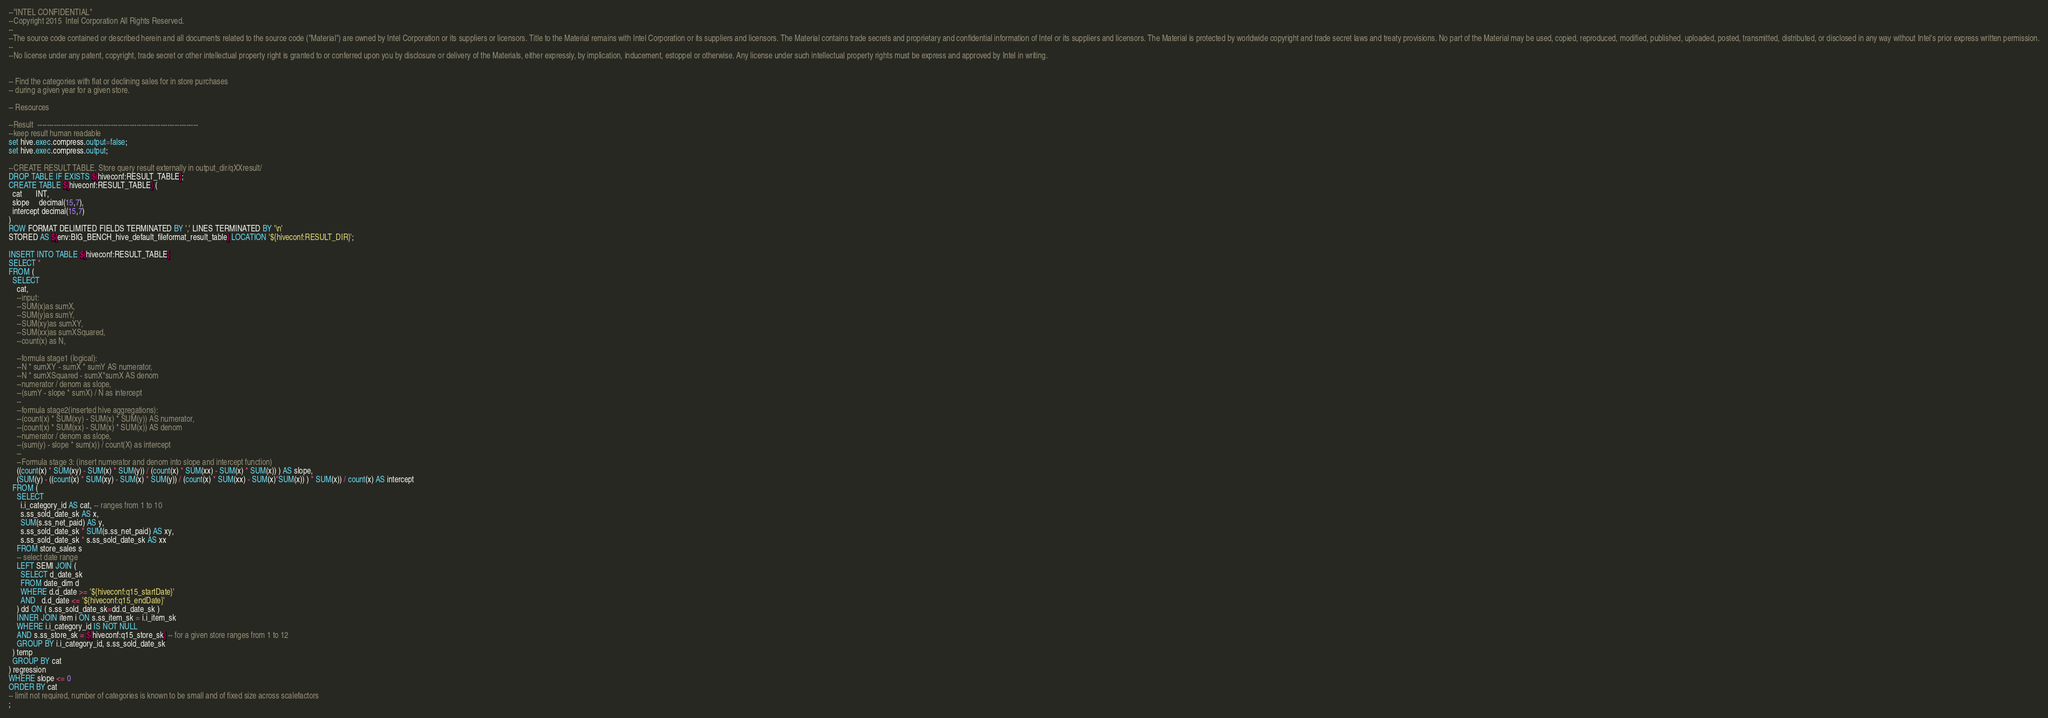Convert code to text. <code><loc_0><loc_0><loc_500><loc_500><_SQL_>--"INTEL CONFIDENTIAL"
--Copyright 2015  Intel Corporation All Rights Reserved.
--
--The source code contained or described herein and all documents related to the source code ("Material") are owned by Intel Corporation or its suppliers or licensors. Title to the Material remains with Intel Corporation or its suppliers and licensors. The Material contains trade secrets and proprietary and confidential information of Intel or its suppliers and licensors. The Material is protected by worldwide copyright and trade secret laws and treaty provisions. No part of the Material may be used, copied, reproduced, modified, published, uploaded, posted, transmitted, distributed, or disclosed in any way without Intel's prior express written permission.
--
--No license under any patent, copyright, trade secret or other intellectual property right is granted to or conferred upon you by disclosure or delivery of the Materials, either expressly, by implication, inducement, estoppel or otherwise. Any license under such intellectual property rights must be express and approved by Intel in writing.


-- Find the categories with flat or declining sales for in store purchases
-- during a given year for a given store.

-- Resources

--Result  --------------------------------------------------------------------
--keep result human readable
set hive.exec.compress.output=false;
set hive.exec.compress.output;

--CREATE RESULT TABLE. Store query result externally in output_dir/qXXresult/
DROP TABLE IF EXISTS ${hiveconf:RESULT_TABLE};
CREATE TABLE ${hiveconf:RESULT_TABLE} (
  cat       INT,
  slope     decimal(15,7),
  intercept decimal(15,7)
)
ROW FORMAT DELIMITED FIELDS TERMINATED BY ',' LINES TERMINATED BY '\n'
STORED AS ${env:BIG_BENCH_hive_default_fileformat_result_table} LOCATION '${hiveconf:RESULT_DIR}';

INSERT INTO TABLE ${hiveconf:RESULT_TABLE}
SELECT *
FROM (
  SELECT
    cat,
    --input:
    --SUM(x)as sumX,
    --SUM(y)as sumY,
    --SUM(xy)as sumXY,
    --SUM(xx)as sumXSquared,
    --count(x) as N,

    --formula stage1 (logical):
    --N * sumXY - sumX * sumY AS numerator,
    --N * sumXSquared - sumX*sumX AS denom
    --numerator / denom as slope,
    --(sumY - slope * sumX) / N as intercept
    --
    --formula stage2(inserted hive aggregations): 
    --(count(x) * SUM(xy) - SUM(x) * SUM(y)) AS numerator,
    --(count(x) * SUM(xx) - SUM(x) * SUM(x)) AS denom
    --numerator / denom as slope,
    --(sum(y) - slope * sum(x)) / count(X) as intercept
    --
    --Formula stage 3: (insert numerator and denom into slope and intercept function)
    ((count(x) * SUM(xy) - SUM(x) * SUM(y)) / (count(x) * SUM(xx) - SUM(x) * SUM(x)) ) AS slope,
    (SUM(y) - ((count(x) * SUM(xy) - SUM(x) * SUM(y)) / (count(x) * SUM(xx) - SUM(x)*SUM(x)) ) * SUM(x)) / count(x) AS intercept
  FROM (
    SELECT
      i.i_category_id AS cat, -- ranges from 1 to 10
      s.ss_sold_date_sk AS x,
      SUM(s.ss_net_paid) AS y,
      s.ss_sold_date_sk * SUM(s.ss_net_paid) AS xy,
      s.ss_sold_date_sk * s.ss_sold_date_sk AS xx
    FROM store_sales s
    -- select date range
    LEFT SEMI JOIN (
      SELECT d_date_sk
      FROM date_dim d
      WHERE d.d_date >= '${hiveconf:q15_startDate}'
      AND   d.d_date <= '${hiveconf:q15_endDate}'
    ) dd ON ( s.ss_sold_date_sk=dd.d_date_sk )
    INNER JOIN item i ON s.ss_item_sk = i.i_item_sk
    WHERE i.i_category_id IS NOT NULL
    AND s.ss_store_sk = ${hiveconf:q15_store_sk} -- for a given store ranges from 1 to 12
    GROUP BY i.i_category_id, s.ss_sold_date_sk
  ) temp
  GROUP BY cat
) regression
WHERE slope <= 0
ORDER BY cat
-- limit not required, number of categories is known to be small and of fixed size across scalefactors
;
</code> 